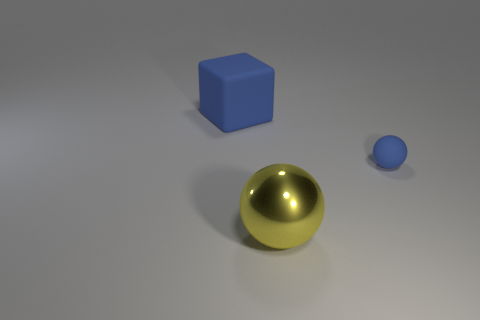There is a large block that is the same color as the tiny object; what is its material? While the large block shares the same blue color as the small object, without additional context or tactile inspection, it's challenging to definitively determine its material based on appearance alone. However, considering the matte surface and the diffuse way it reflects light, a plausible assumption would be that the block is made of a non-metallic substance, such as plastic or painted wood. 